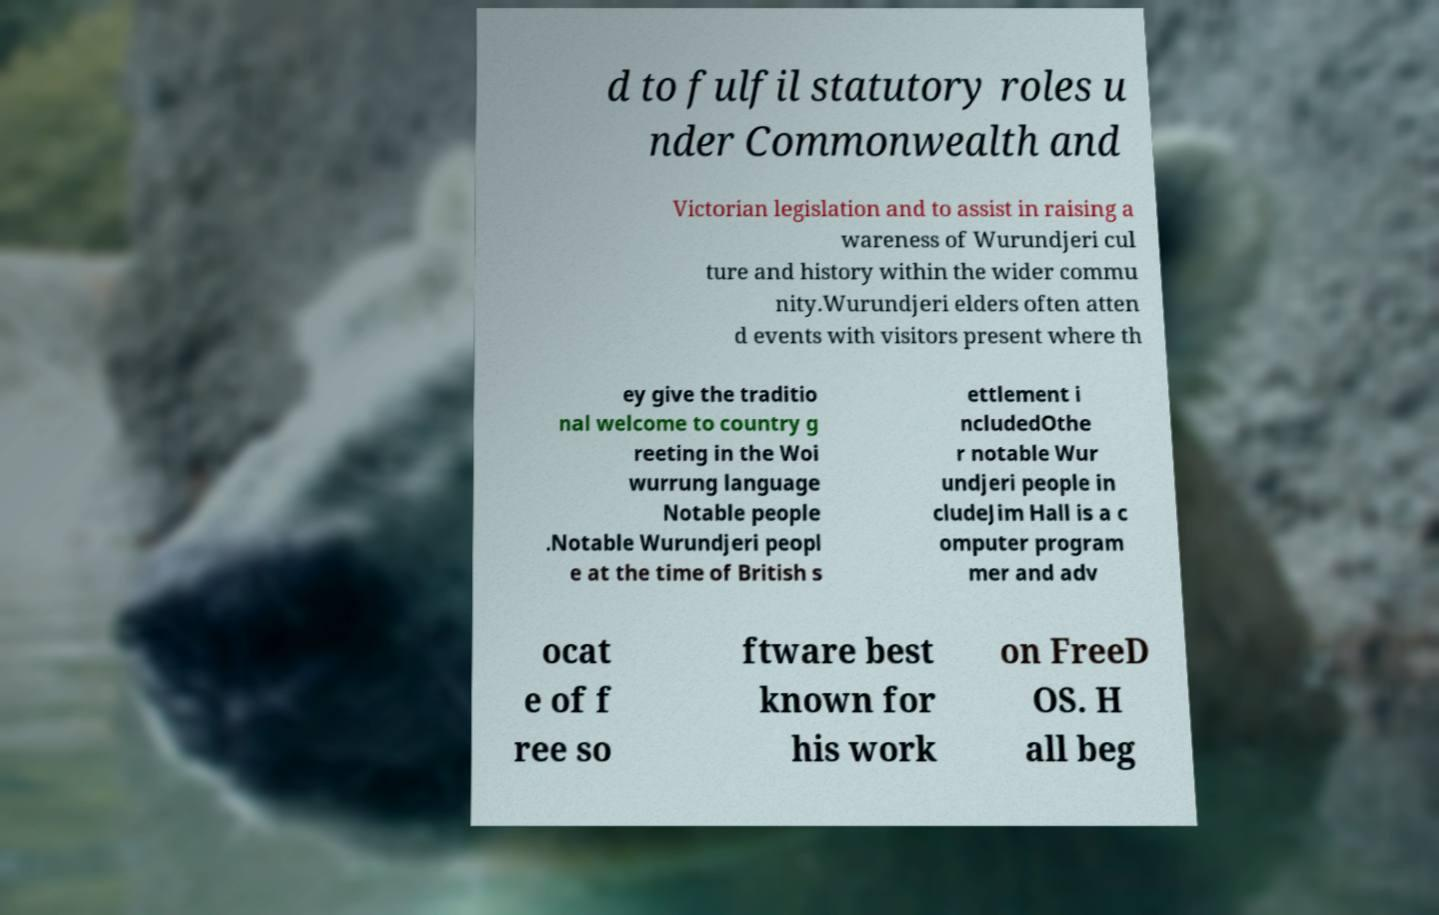Could you assist in decoding the text presented in this image and type it out clearly? d to fulfil statutory roles u nder Commonwealth and Victorian legislation and to assist in raising a wareness of Wurundjeri cul ture and history within the wider commu nity.Wurundjeri elders often atten d events with visitors present where th ey give the traditio nal welcome to country g reeting in the Woi wurrung language Notable people .Notable Wurundjeri peopl e at the time of British s ettlement i ncludedOthe r notable Wur undjeri people in cludeJim Hall is a c omputer program mer and adv ocat e of f ree so ftware best known for his work on FreeD OS. H all beg 